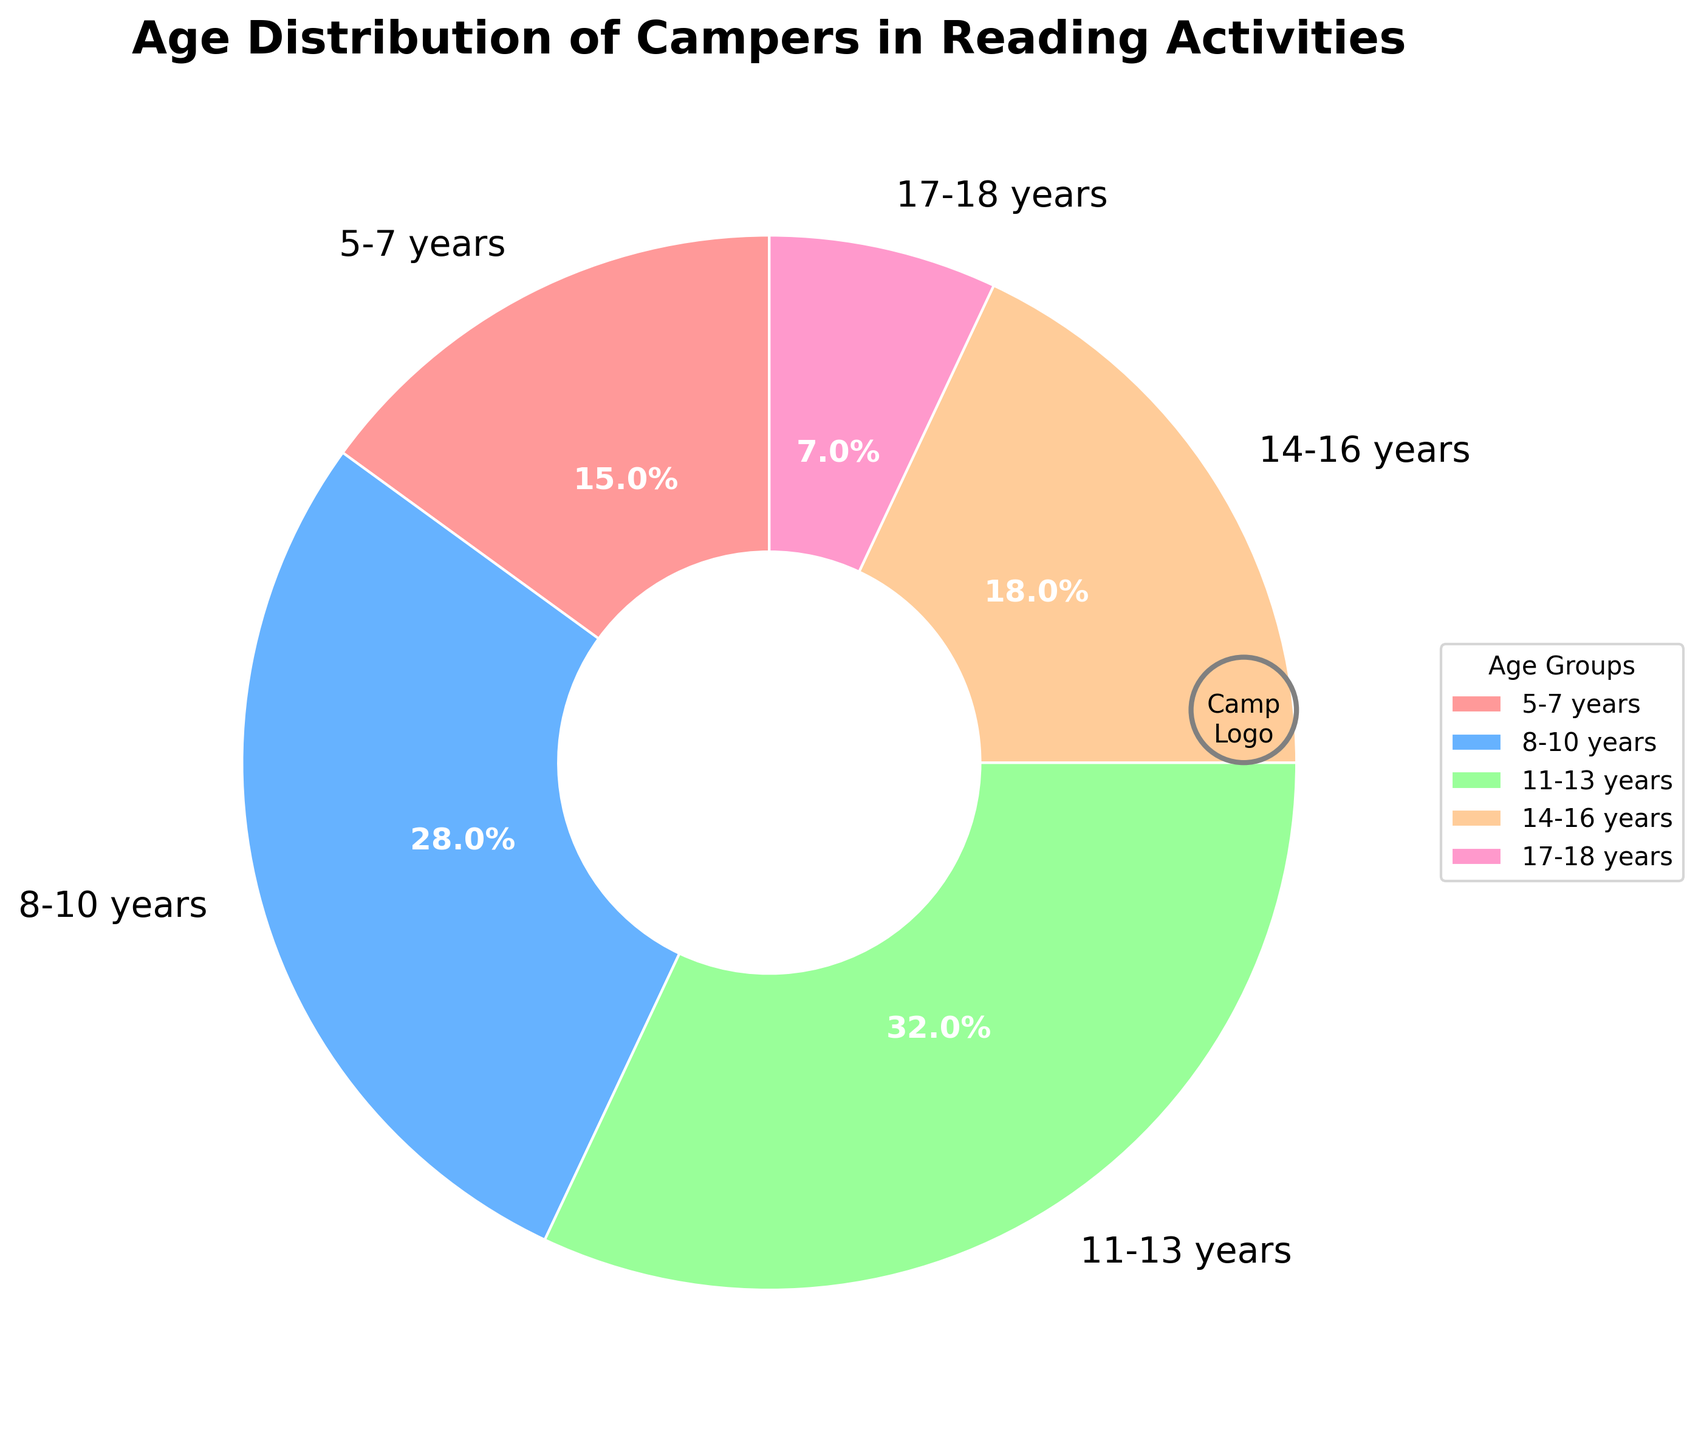What's the total percentage of campers aged between 8 and 13 years? First, find the percentage for the 8-10 years group (28%) and the 11-13 years group (32%). Add these percentages together: 28 + 32 = 60. So, the total percentage of campers aged between 8 and 13 years is 60%
Answer: 60% Which age group has the highest percentage of campers? Look at the pie chart and find the age group with the largest wedge. The 11-13 years group corresponds to the largest wedge with 32%
Answer: 11-13 years Which age group has the lowest percentage of campers? Find the smallest wedge in the pie chart. The 17-18 years group has the smallest wedge (7%)
Answer: 17-18 years What's the percentage difference between the 8-10 years and 14-16 years age groups? Find the percentages of the 8-10 years (28%) and the 14-16 years (18%) groups. Subtract to find the difference: 28 - 18 = 10
Answer: 10% How do the combined percentages of the youngest and oldest age groups compare to the percentage of the 11-13 years group? Add the percentages of the youngest (5-7 years, 15%) and the oldest (17-18 years, 7%) age groups: 15 + 7 = 22. Compare this to the 11-13 years group's percentage (32%). 22 is less than 32
Answer: Less What is the percentage of campers aged 14-18 years? Add the percentages of the 14-16 years (18%) and 17-18 years (7%) groups together: 18 + 7 = 25
Answer: 25% Which color is used to represent the 5-7 years age group in the chart? Look at the color of the wedge labeled "5-7 years" in the pie chart. The color appears to be red
Answer: Red What is the combined percentage of campers in the two smallest age groups by percentage? Find the percentages for the smallest age groups: 5-7 years (15%) and 17-18 years (7%). Add them together: 15 + 7 = 22
Answer: 22% Among the 5-7 years and 14-16 years groups, which has a higher percentage of campers? Compare the percentages: 5-7 years (15%) and 14-16 years (18%). The 14-16 years group is larger
Answer: 14-16 years What is the difference in percentage between the 8-10 years group and the 5-7 years group? Subtract the percentage of the 5-7 years group (15%) from the 8-10 years group (28%): 28 - 15 = 13
Answer: 13 